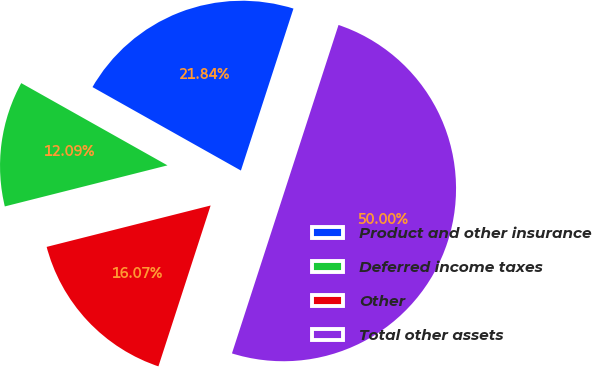Convert chart. <chart><loc_0><loc_0><loc_500><loc_500><pie_chart><fcel>Product and other insurance<fcel>Deferred income taxes<fcel>Other<fcel>Total other assets<nl><fcel>21.84%<fcel>12.09%<fcel>16.07%<fcel>50.0%<nl></chart> 